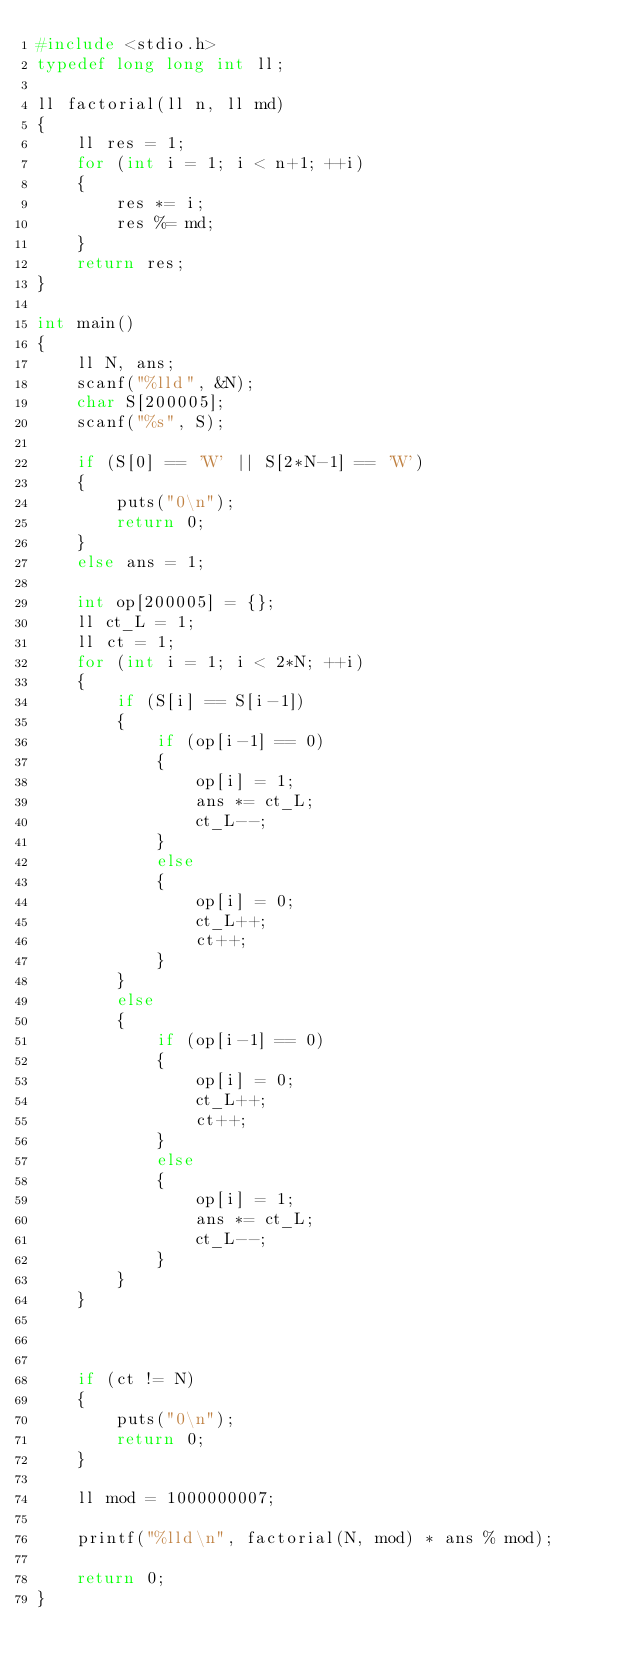Convert code to text. <code><loc_0><loc_0><loc_500><loc_500><_C_>#include <stdio.h>
typedef long long int ll;

ll factorial(ll n, ll md)
{
    ll res = 1;
    for (int i = 1; i < n+1; ++i)
    {
        res *= i;
        res %= md;
    }
    return res;
}

int main()
{
    ll N, ans;
    scanf("%lld", &N);
    char S[200005];
    scanf("%s", S);

    if (S[0] == 'W' || S[2*N-1] == 'W')
    {
        puts("0\n");
        return 0;
    }
    else ans = 1;

    int op[200005] = {};
    ll ct_L = 1;
    ll ct = 1;
    for (int i = 1; i < 2*N; ++i)
    {
        if (S[i] == S[i-1])
        {
            if (op[i-1] == 0)
            {
                op[i] = 1;
                ans *= ct_L;
                ct_L--;
            }
            else
            {
                op[i] = 0;
                ct_L++;
                ct++;
            }
        }
        else
        {
            if (op[i-1] == 0)
            {
                op[i] = 0;
                ct_L++;
                ct++;
            }
            else
            {
                op[i] = 1;
                ans *= ct_L;
                ct_L--;
            }
        }
    }



    if (ct != N)
    {
        puts("0\n");
        return 0;
    }

    ll mod = 1000000007;

    printf("%lld\n", factorial(N, mod) * ans % mod);

    return 0;
}
</code> 